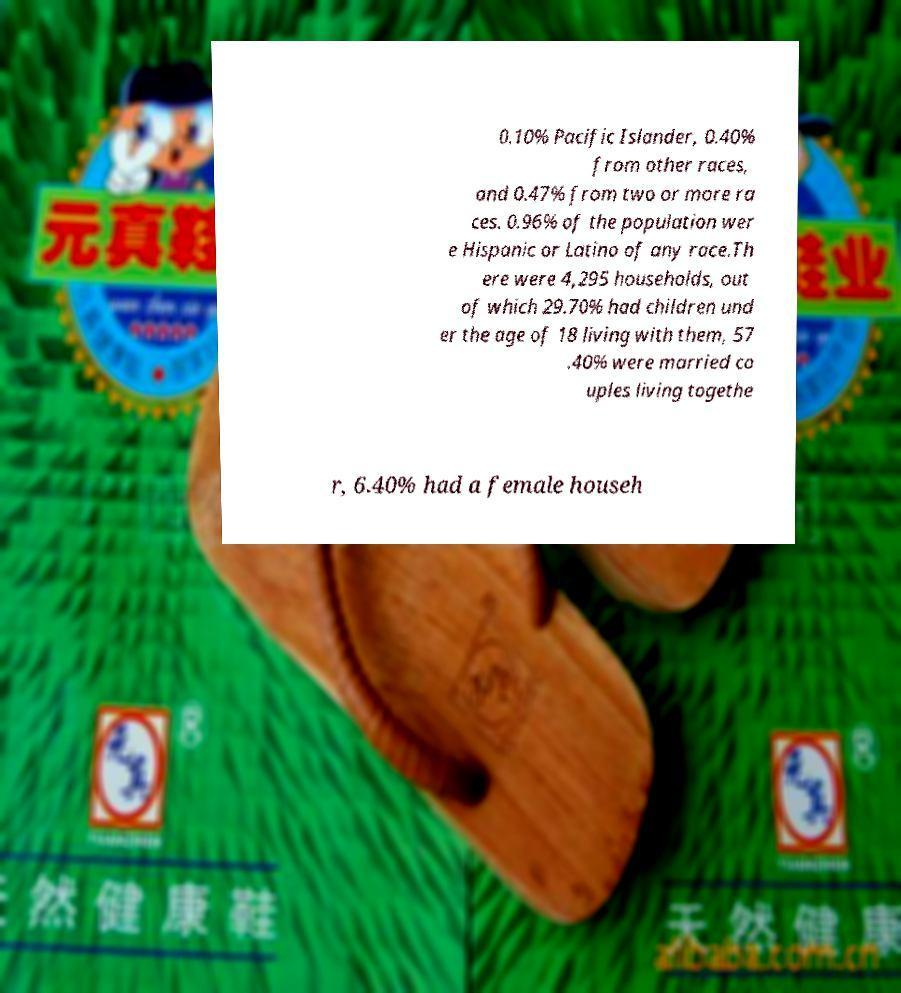I need the written content from this picture converted into text. Can you do that? 0.10% Pacific Islander, 0.40% from other races, and 0.47% from two or more ra ces. 0.96% of the population wer e Hispanic or Latino of any race.Th ere were 4,295 households, out of which 29.70% had children und er the age of 18 living with them, 57 .40% were married co uples living togethe r, 6.40% had a female househ 